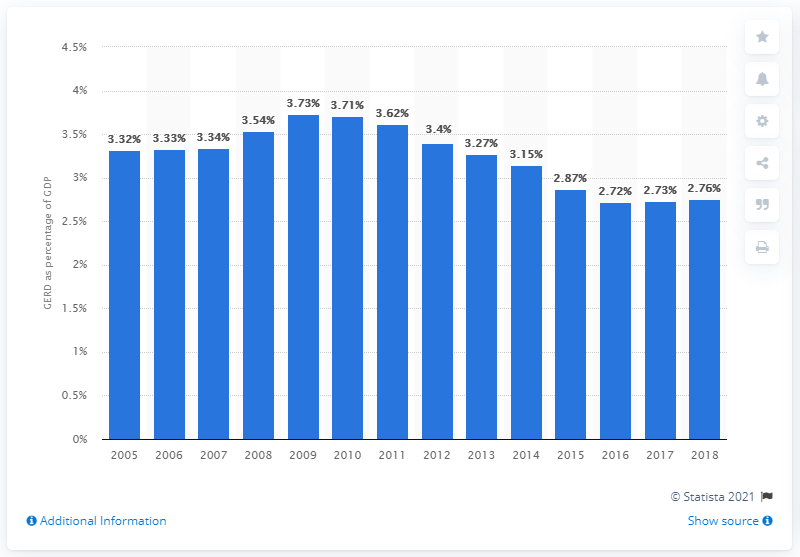Outline some significant characteristics in this image. In 2018, Finland's GDP was allocated 2.76% towards research and development. 